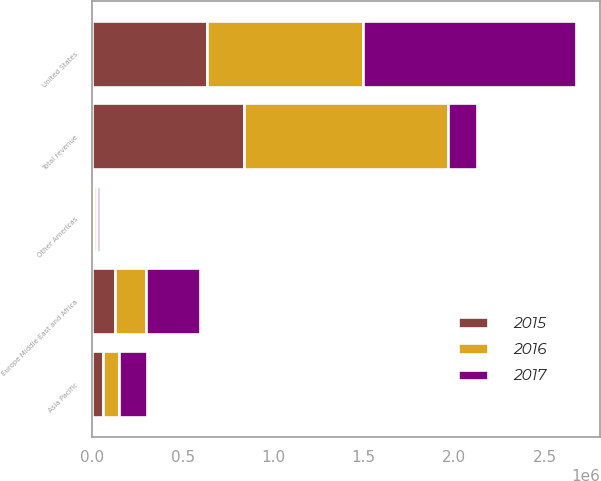Convert chart. <chart><loc_0><loc_0><loc_500><loc_500><stacked_bar_chart><ecel><fcel>United States<fcel>Other Americas<fcel>Europe Middle East and Africa<fcel>Asia Pacific<fcel>Total revenue<nl><fcel>2017<fcel>1.1747e+06<fcel>17584<fcel>299547<fcel>154350<fcel>161570<nl><fcel>2016<fcel>862352<fcel>12388<fcel>168789<fcel>85638<fcel>1.12917e+06<nl><fcel>2015<fcel>634413<fcel>12506<fcel>128400<fcel>62272<fcel>837591<nl></chart> 